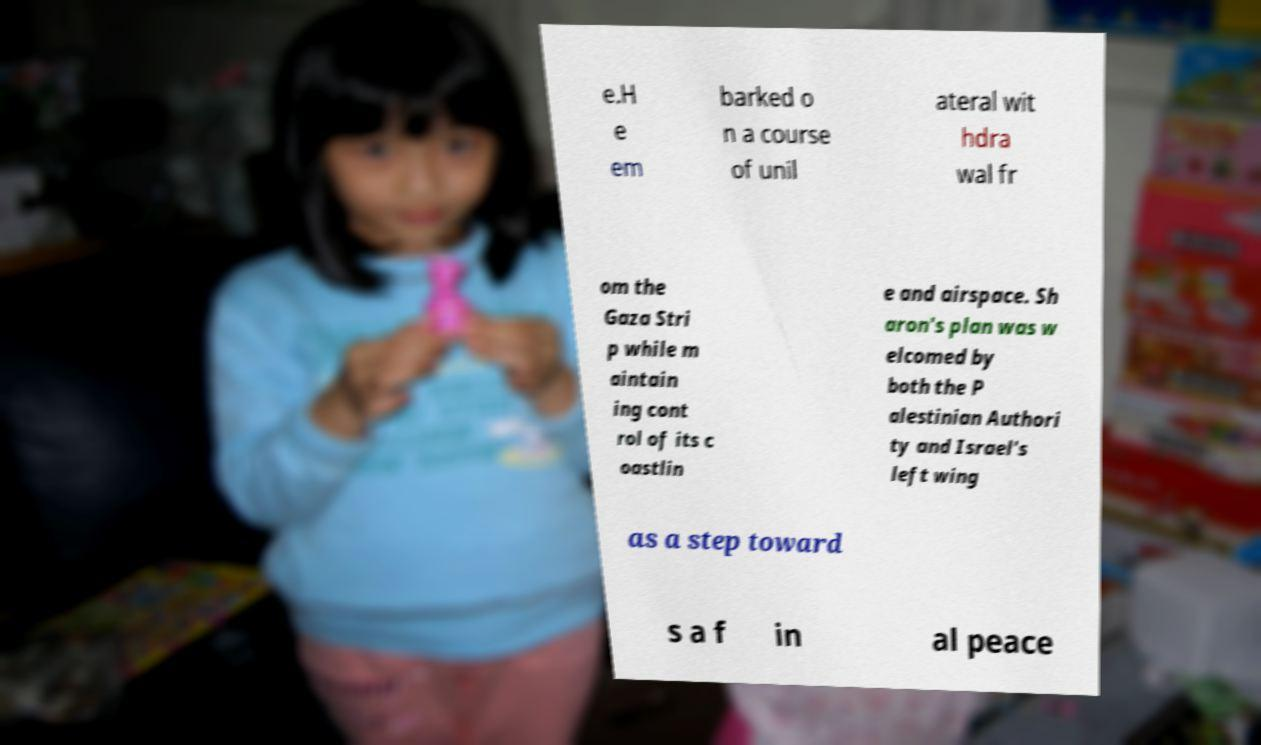Please identify and transcribe the text found in this image. e.H e em barked o n a course of unil ateral wit hdra wal fr om the Gaza Stri p while m aintain ing cont rol of its c oastlin e and airspace. Sh aron's plan was w elcomed by both the P alestinian Authori ty and Israel's left wing as a step toward s a f in al peace 